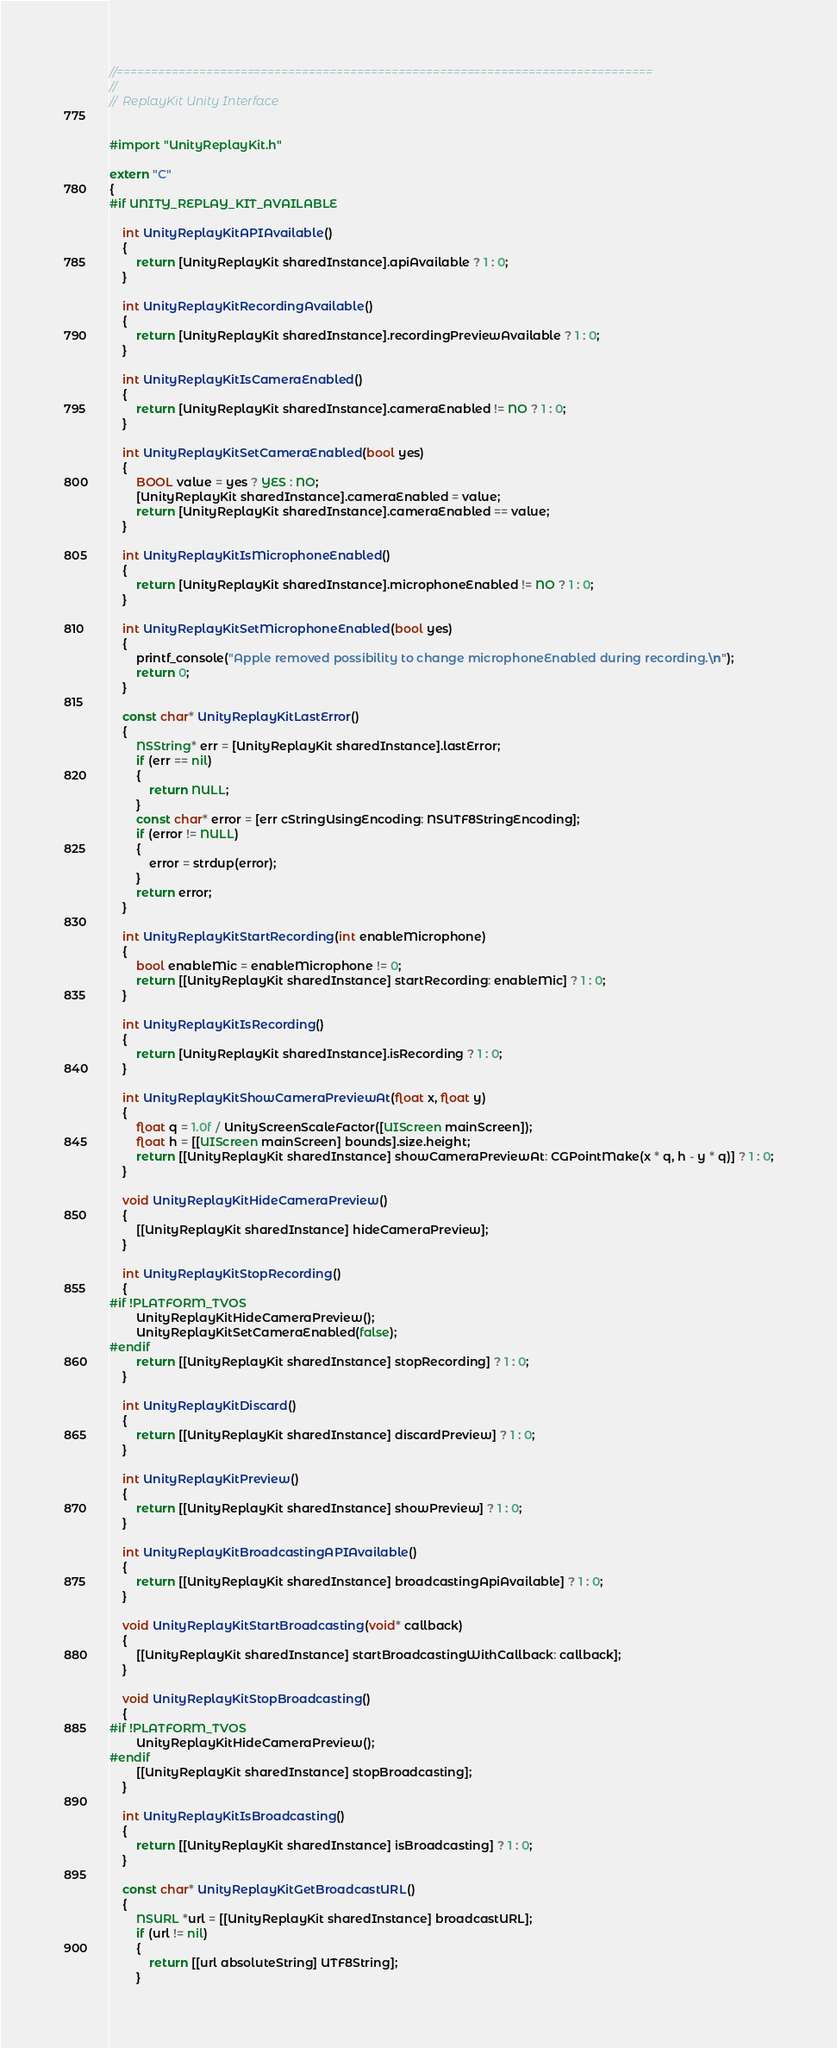Convert code to text. <code><loc_0><loc_0><loc_500><loc_500><_ObjectiveC_>//==============================================================================
//
//  ReplayKit Unity Interface


#import "UnityReplayKit.h"

extern "C"
{
#if UNITY_REPLAY_KIT_AVAILABLE

    int UnityReplayKitAPIAvailable()
    {
        return [UnityReplayKit sharedInstance].apiAvailable ? 1 : 0;
    }

    int UnityReplayKitRecordingAvailable()
    {
        return [UnityReplayKit sharedInstance].recordingPreviewAvailable ? 1 : 0;
    }

    int UnityReplayKitIsCameraEnabled()
    {
        return [UnityReplayKit sharedInstance].cameraEnabled != NO ? 1 : 0;
    }

    int UnityReplayKitSetCameraEnabled(bool yes)
    {
        BOOL value = yes ? YES : NO;
        [UnityReplayKit sharedInstance].cameraEnabled = value;
        return [UnityReplayKit sharedInstance].cameraEnabled == value;
    }

    int UnityReplayKitIsMicrophoneEnabled()
    {
        return [UnityReplayKit sharedInstance].microphoneEnabled != NO ? 1 : 0;
    }

    int UnityReplayKitSetMicrophoneEnabled(bool yes)
    {
        printf_console("Apple removed possibility to change microphoneEnabled during recording.\n");
        return 0;
    }

    const char* UnityReplayKitLastError()
    {
        NSString* err = [UnityReplayKit sharedInstance].lastError;
        if (err == nil)
        {
            return NULL;
        }
        const char* error = [err cStringUsingEncoding: NSUTF8StringEncoding];
        if (error != NULL)
        {
            error = strdup(error);
        }
        return error;
    }

    int UnityReplayKitStartRecording(int enableMicrophone)
    {
        bool enableMic = enableMicrophone != 0;
        return [[UnityReplayKit sharedInstance] startRecording: enableMic] ? 1 : 0;
    }

    int UnityReplayKitIsRecording()
    {
        return [UnityReplayKit sharedInstance].isRecording ? 1 : 0;
    }

    int UnityReplayKitShowCameraPreviewAt(float x, float y)
    {
        float q = 1.0f / UnityScreenScaleFactor([UIScreen mainScreen]);
        float h = [[UIScreen mainScreen] bounds].size.height;
        return [[UnityReplayKit sharedInstance] showCameraPreviewAt: CGPointMake(x * q, h - y * q)] ? 1 : 0;
    }

    void UnityReplayKitHideCameraPreview()
    {
        [[UnityReplayKit sharedInstance] hideCameraPreview];
    }

    int UnityReplayKitStopRecording()
    {
#if !PLATFORM_TVOS
        UnityReplayKitHideCameraPreview();
        UnityReplayKitSetCameraEnabled(false);
#endif
        return [[UnityReplayKit sharedInstance] stopRecording] ? 1 : 0;
    }

    int UnityReplayKitDiscard()
    {
        return [[UnityReplayKit sharedInstance] discardPreview] ? 1 : 0;
    }

    int UnityReplayKitPreview()
    {
        return [[UnityReplayKit sharedInstance] showPreview] ? 1 : 0;
    }

    int UnityReplayKitBroadcastingAPIAvailable()
    {
        return [[UnityReplayKit sharedInstance] broadcastingApiAvailable] ? 1 : 0;
    }

    void UnityReplayKitStartBroadcasting(void* callback)
    {
        [[UnityReplayKit sharedInstance] startBroadcastingWithCallback: callback];
    }

    void UnityReplayKitStopBroadcasting()
    {
#if !PLATFORM_TVOS
        UnityReplayKitHideCameraPreview();
#endif
        [[UnityReplayKit sharedInstance] stopBroadcasting];
    }

    int UnityReplayKitIsBroadcasting()
    {
        return [[UnityReplayKit sharedInstance] isBroadcasting] ? 1 : 0;
    }

    const char* UnityReplayKitGetBroadcastURL()
    {
        NSURL *url = [[UnityReplayKit sharedInstance] broadcastURL];
        if (url != nil)
        {
            return [[url absoluteString] UTF8String];
        }</code> 